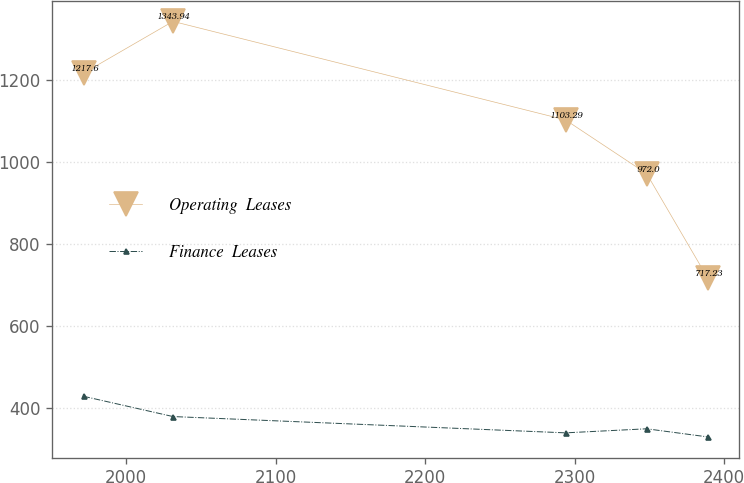Convert chart to OTSL. <chart><loc_0><loc_0><loc_500><loc_500><line_chart><ecel><fcel>Operating  Leases<fcel>Finance  Leases<nl><fcel>1971.56<fcel>1217.6<fcel>428.5<nl><fcel>2031.36<fcel>1343.94<fcel>379.07<nl><fcel>2293.94<fcel>1103.29<fcel>339.29<nl><fcel>2348.2<fcel>972<fcel>349.2<nl><fcel>2389<fcel>717.23<fcel>329.38<nl></chart> 